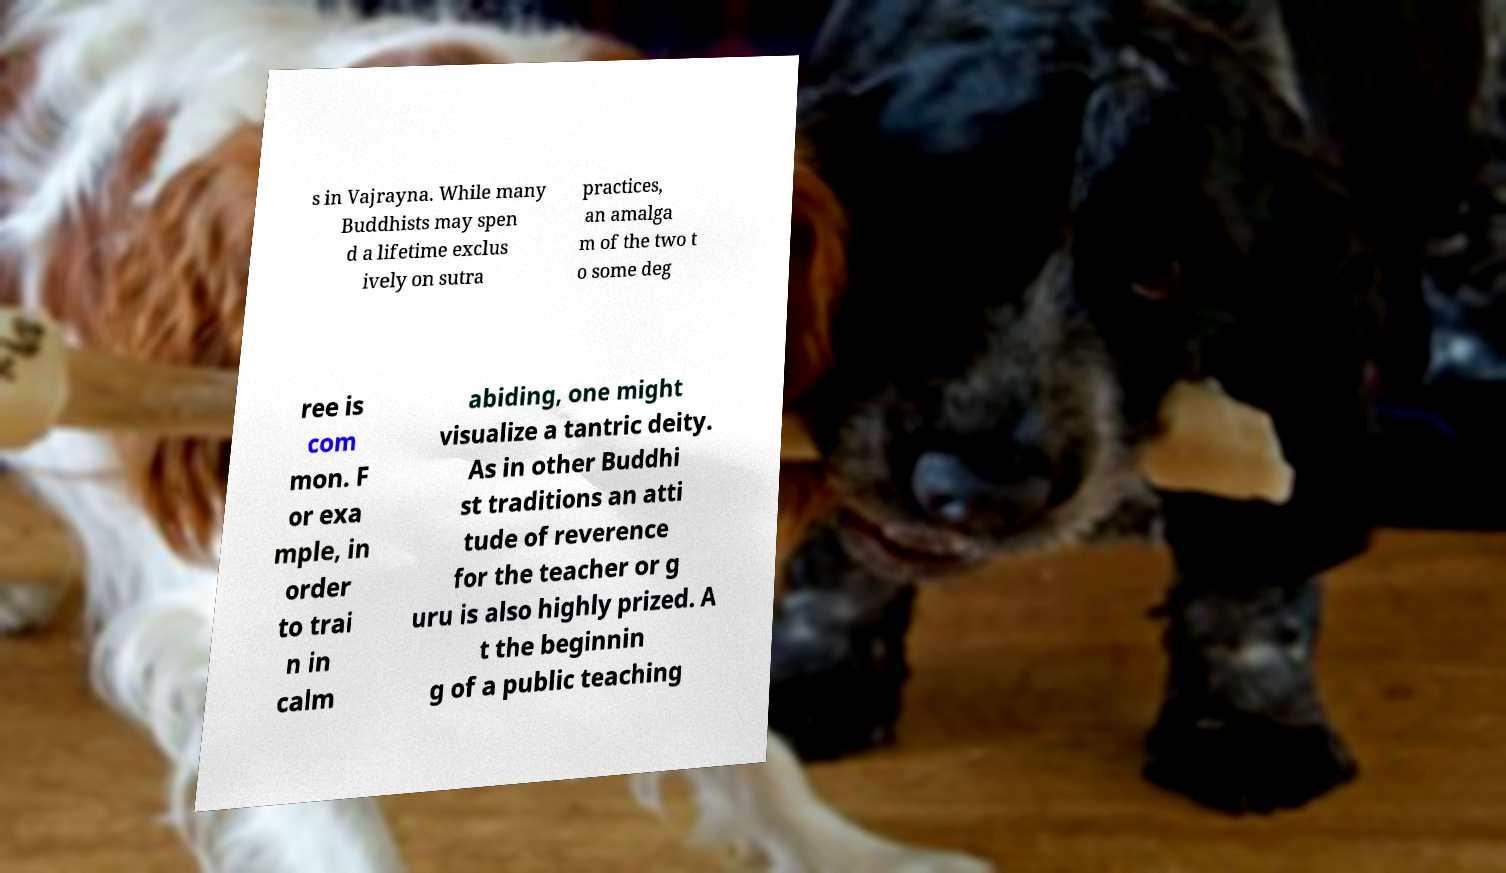Please read and relay the text visible in this image. What does it say? s in Vajrayna. While many Buddhists may spen d a lifetime exclus ively on sutra practices, an amalga m of the two t o some deg ree is com mon. F or exa mple, in order to trai n in calm abiding, one might visualize a tantric deity. As in other Buddhi st traditions an atti tude of reverence for the teacher or g uru is also highly prized. A t the beginnin g of a public teaching 